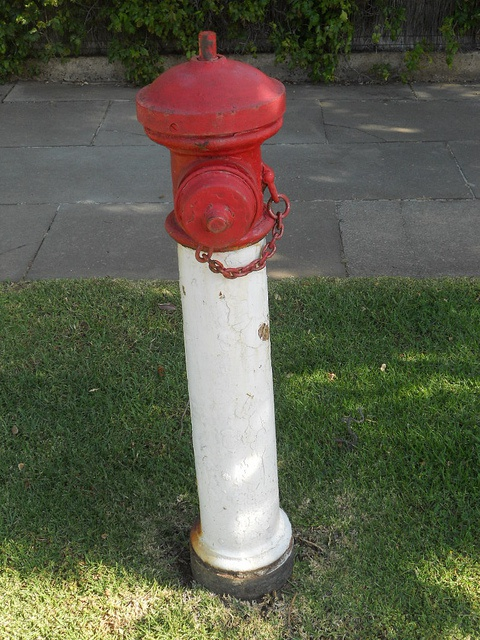Describe the objects in this image and their specific colors. I can see a fire hydrant in black, lightgray, brown, and gray tones in this image. 